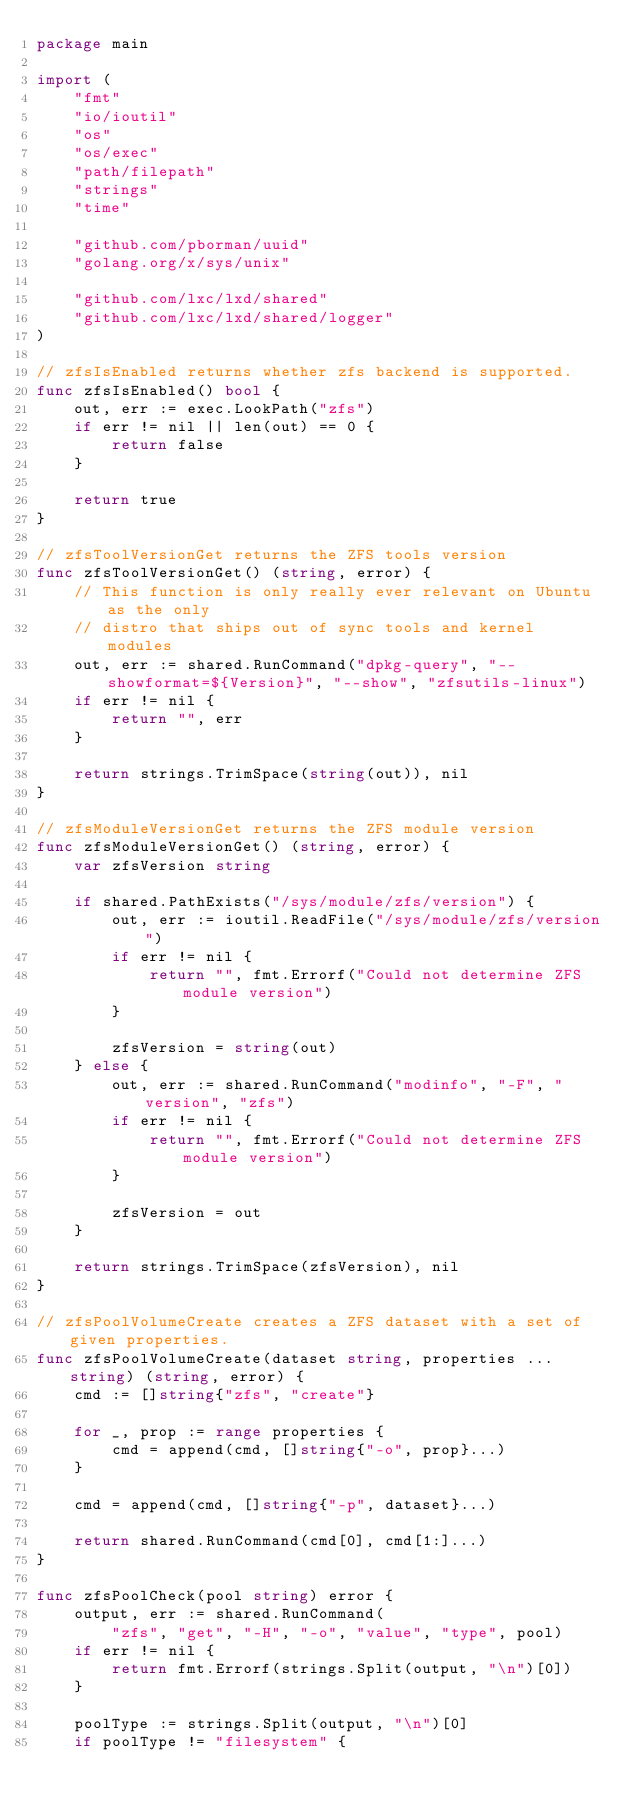Convert code to text. <code><loc_0><loc_0><loc_500><loc_500><_Go_>package main

import (
	"fmt"
	"io/ioutil"
	"os"
	"os/exec"
	"path/filepath"
	"strings"
	"time"

	"github.com/pborman/uuid"
	"golang.org/x/sys/unix"

	"github.com/lxc/lxd/shared"
	"github.com/lxc/lxd/shared/logger"
)

// zfsIsEnabled returns whether zfs backend is supported.
func zfsIsEnabled() bool {
	out, err := exec.LookPath("zfs")
	if err != nil || len(out) == 0 {
		return false
	}

	return true
}

// zfsToolVersionGet returns the ZFS tools version
func zfsToolVersionGet() (string, error) {
	// This function is only really ever relevant on Ubuntu as the only
	// distro that ships out of sync tools and kernel modules
	out, err := shared.RunCommand("dpkg-query", "--showformat=${Version}", "--show", "zfsutils-linux")
	if err != nil {
		return "", err
	}

	return strings.TrimSpace(string(out)), nil
}

// zfsModuleVersionGet returns the ZFS module version
func zfsModuleVersionGet() (string, error) {
	var zfsVersion string

	if shared.PathExists("/sys/module/zfs/version") {
		out, err := ioutil.ReadFile("/sys/module/zfs/version")
		if err != nil {
			return "", fmt.Errorf("Could not determine ZFS module version")
		}

		zfsVersion = string(out)
	} else {
		out, err := shared.RunCommand("modinfo", "-F", "version", "zfs")
		if err != nil {
			return "", fmt.Errorf("Could not determine ZFS module version")
		}

		zfsVersion = out
	}

	return strings.TrimSpace(zfsVersion), nil
}

// zfsPoolVolumeCreate creates a ZFS dataset with a set of given properties.
func zfsPoolVolumeCreate(dataset string, properties ...string) (string, error) {
	cmd := []string{"zfs", "create"}

	for _, prop := range properties {
		cmd = append(cmd, []string{"-o", prop}...)
	}

	cmd = append(cmd, []string{"-p", dataset}...)

	return shared.RunCommand(cmd[0], cmd[1:]...)
}

func zfsPoolCheck(pool string) error {
	output, err := shared.RunCommand(
		"zfs", "get", "-H", "-o", "value", "type", pool)
	if err != nil {
		return fmt.Errorf(strings.Split(output, "\n")[0])
	}

	poolType := strings.Split(output, "\n")[0]
	if poolType != "filesystem" {</code> 